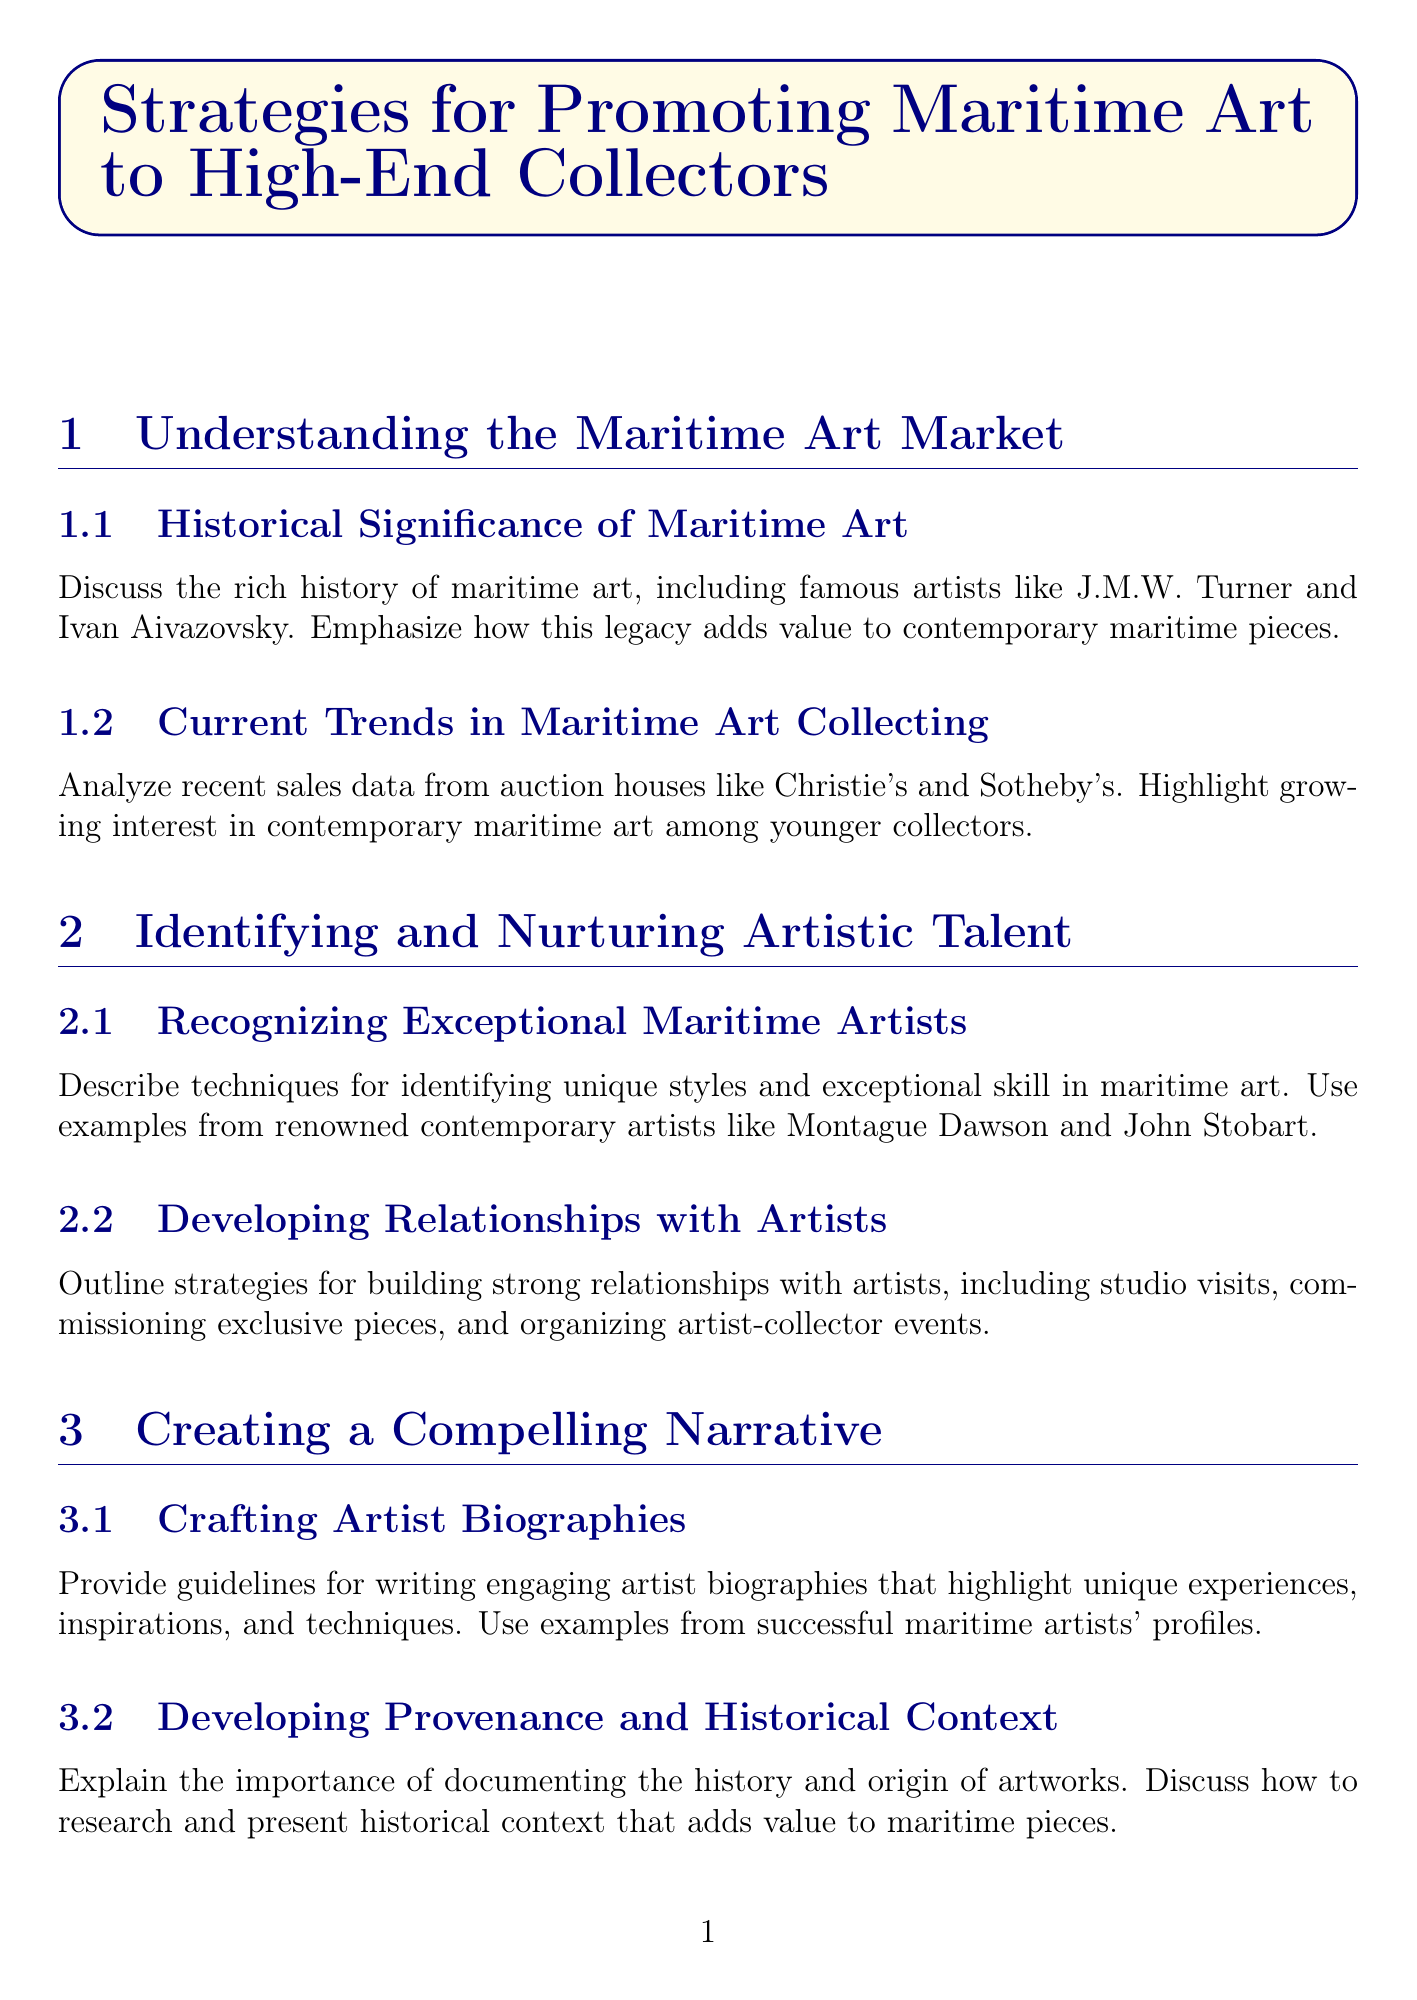What famous artists are mentioned in relation to the historical significance of maritime art? The document refers to notable artists such as J.M.W. Turner and Ivan Aivazovsky when discussing maritime art's historical significance.
Answer: J.M.W. Turner, Ivan Aivazovsky What is the focus of the Current Trends in Maritime Art Collecting section? This section analyzes recent sales data from auction houses and highlights the growing interest in contemporary maritime art among younger collectors.
Answer: Growing interest in contemporary maritime art Which renowned contemporary artists are used as examples for recognizing exceptional maritime artists? The document mentions Montague Dawson and John Stobart as examples of renowned contemporary maritime artists.
Answer: Montague Dawson, John Stobart What type of events are suggested for building stronger relationships with artists? The document outlines strategies including studio visits, commissioning pieces, and organizing events that engage both artists and collectors.
Answer: Artist-collector events Which platforms are suggested for utilizing social media to promote maritime artworks? Strategies in the document suggest using Instagram, Facebook, and Twitter to showcase maritime artworks and engage potential collectors.
Answer: Instagram, Facebook, Twitter What is the purpose of creating a compelling narrative for maritime art? The document emphasizes the importance of crafting engaging artist biographies and developing provenance to add value to maritime pieces.
Answer: Add value What is one method mentioned for identifying potential high-end collectors? The document suggests using wealth intelligence platforms such as Wealth-X to research and connect with wealthy individuals interested in maritime art.
Answer: Wealth-X What auction houses are referenced for strategically placing maritime artworks? The document discusses the process of consigning artworks to major auction houses like Bonhams and Phillips.
Answer: Bonhams, Phillips What unique experience is highlighted in the Leveraging Digital Marketing section? The document refers to the use of virtual reality and 360-degree video tours to showcase maritime art collections.
Answer: Virtual reality and 360-degree video tours 